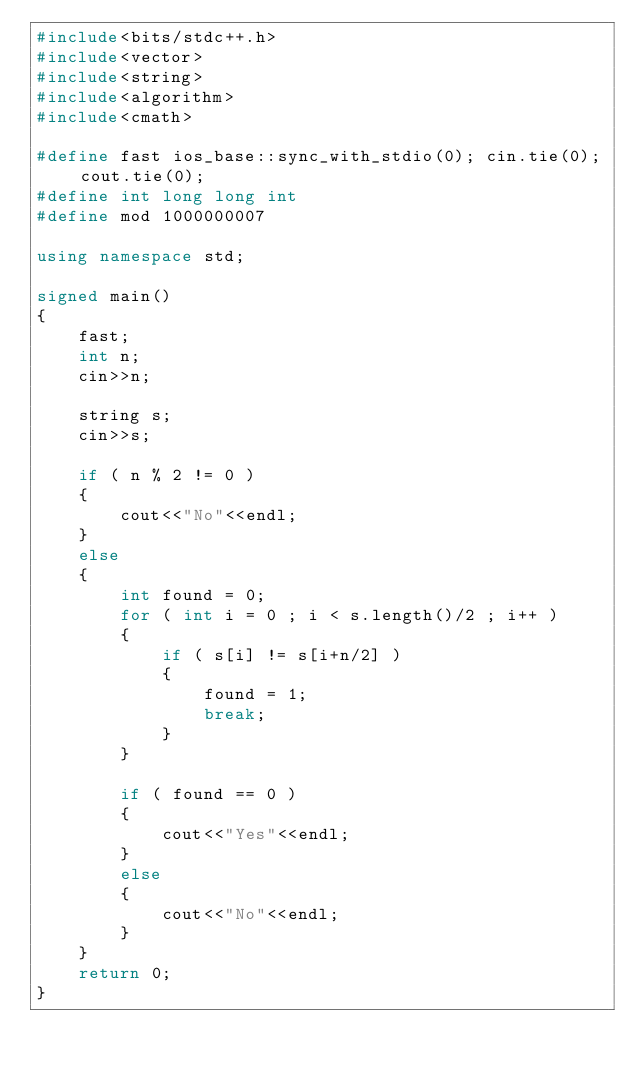<code> <loc_0><loc_0><loc_500><loc_500><_C++_>#include<bits/stdc++.h>
#include<vector>
#include<string>
#include<algorithm>
#include<cmath>
 
#define fast ios_base::sync_with_stdio(0); cin.tie(0); cout.tie(0);
#define int long long int
#define mod 1000000007
 
using namespace std;
 
signed main()
{
    fast;
    int n;
    cin>>n;

    string s;
    cin>>s;

    if ( n % 2 != 0 )
    {
        cout<<"No"<<endl;
    }
    else
    {
        int found = 0;
        for ( int i = 0 ; i < s.length()/2 ; i++ )
        {
            if ( s[i] != s[i+n/2] )
            {
                found = 1;
                break;
            }
        }

        if ( found == 0 )
        {
            cout<<"Yes"<<endl;
        }
        else
        {
            cout<<"No"<<endl;
        }
    }
    return 0;
}</code> 